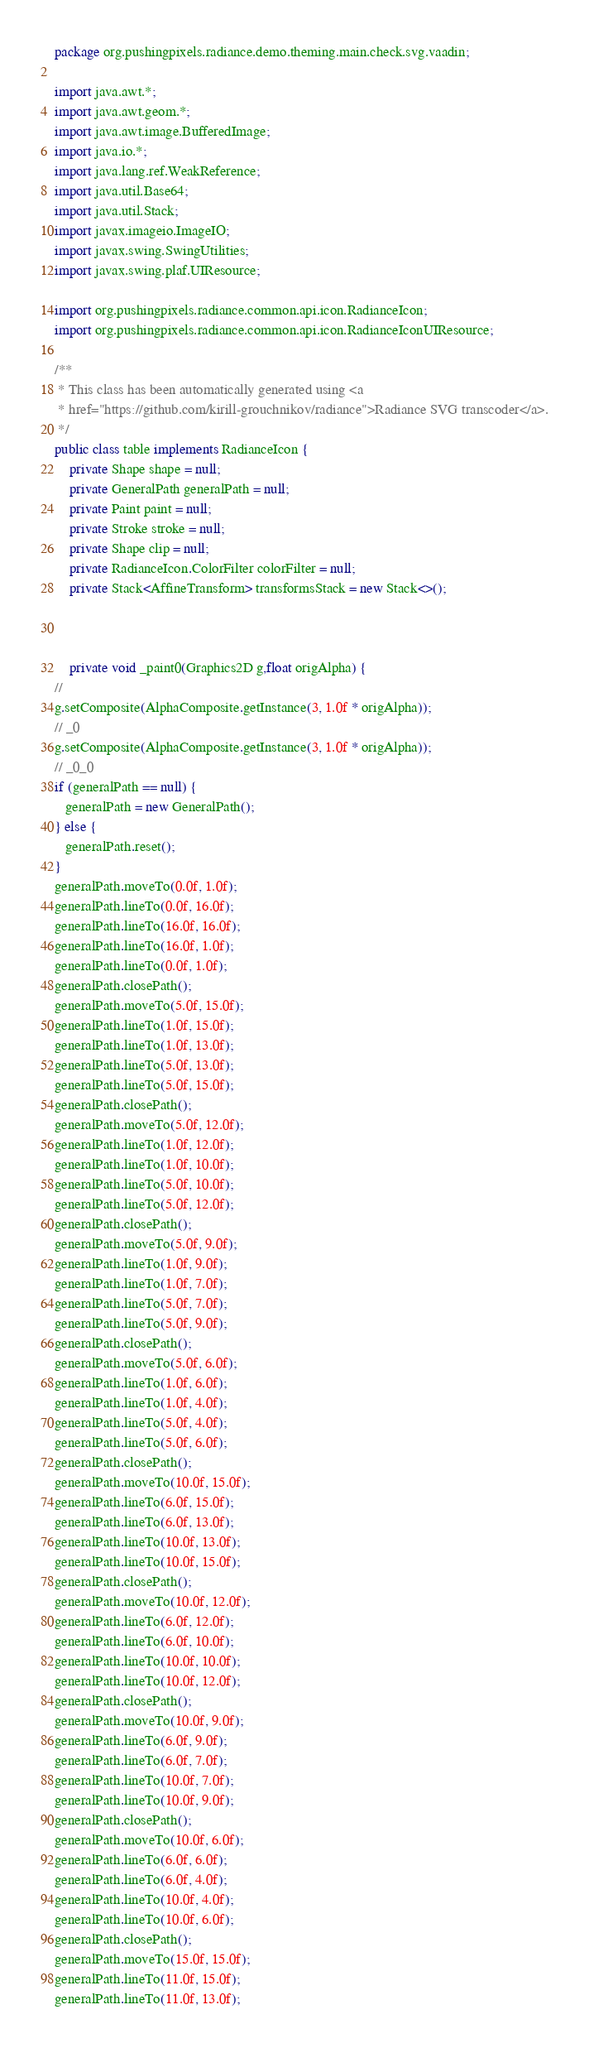<code> <loc_0><loc_0><loc_500><loc_500><_Java_>package org.pushingpixels.radiance.demo.theming.main.check.svg.vaadin;

import java.awt.*;
import java.awt.geom.*;
import java.awt.image.BufferedImage;
import java.io.*;
import java.lang.ref.WeakReference;
import java.util.Base64;
import java.util.Stack;
import javax.imageio.ImageIO;
import javax.swing.SwingUtilities;
import javax.swing.plaf.UIResource;

import org.pushingpixels.radiance.common.api.icon.RadianceIcon;
import org.pushingpixels.radiance.common.api.icon.RadianceIconUIResource;

/**
 * This class has been automatically generated using <a
 * href="https://github.com/kirill-grouchnikov/radiance">Radiance SVG transcoder</a>.
 */
public class table implements RadianceIcon {
    private Shape shape = null;
    private GeneralPath generalPath = null;
    private Paint paint = null;
    private Stroke stroke = null;
    private Shape clip = null;
    private RadianceIcon.ColorFilter colorFilter = null;
    private Stack<AffineTransform> transformsStack = new Stack<>();

    

	private void _paint0(Graphics2D g,float origAlpha) {
// 
g.setComposite(AlphaComposite.getInstance(3, 1.0f * origAlpha));
// _0
g.setComposite(AlphaComposite.getInstance(3, 1.0f * origAlpha));
// _0_0
if (generalPath == null) {
   generalPath = new GeneralPath();
} else {
   generalPath.reset();
}
generalPath.moveTo(0.0f, 1.0f);
generalPath.lineTo(0.0f, 16.0f);
generalPath.lineTo(16.0f, 16.0f);
generalPath.lineTo(16.0f, 1.0f);
generalPath.lineTo(0.0f, 1.0f);
generalPath.closePath();
generalPath.moveTo(5.0f, 15.0f);
generalPath.lineTo(1.0f, 15.0f);
generalPath.lineTo(1.0f, 13.0f);
generalPath.lineTo(5.0f, 13.0f);
generalPath.lineTo(5.0f, 15.0f);
generalPath.closePath();
generalPath.moveTo(5.0f, 12.0f);
generalPath.lineTo(1.0f, 12.0f);
generalPath.lineTo(1.0f, 10.0f);
generalPath.lineTo(5.0f, 10.0f);
generalPath.lineTo(5.0f, 12.0f);
generalPath.closePath();
generalPath.moveTo(5.0f, 9.0f);
generalPath.lineTo(1.0f, 9.0f);
generalPath.lineTo(1.0f, 7.0f);
generalPath.lineTo(5.0f, 7.0f);
generalPath.lineTo(5.0f, 9.0f);
generalPath.closePath();
generalPath.moveTo(5.0f, 6.0f);
generalPath.lineTo(1.0f, 6.0f);
generalPath.lineTo(1.0f, 4.0f);
generalPath.lineTo(5.0f, 4.0f);
generalPath.lineTo(5.0f, 6.0f);
generalPath.closePath();
generalPath.moveTo(10.0f, 15.0f);
generalPath.lineTo(6.0f, 15.0f);
generalPath.lineTo(6.0f, 13.0f);
generalPath.lineTo(10.0f, 13.0f);
generalPath.lineTo(10.0f, 15.0f);
generalPath.closePath();
generalPath.moveTo(10.0f, 12.0f);
generalPath.lineTo(6.0f, 12.0f);
generalPath.lineTo(6.0f, 10.0f);
generalPath.lineTo(10.0f, 10.0f);
generalPath.lineTo(10.0f, 12.0f);
generalPath.closePath();
generalPath.moveTo(10.0f, 9.0f);
generalPath.lineTo(6.0f, 9.0f);
generalPath.lineTo(6.0f, 7.0f);
generalPath.lineTo(10.0f, 7.0f);
generalPath.lineTo(10.0f, 9.0f);
generalPath.closePath();
generalPath.moveTo(10.0f, 6.0f);
generalPath.lineTo(6.0f, 6.0f);
generalPath.lineTo(6.0f, 4.0f);
generalPath.lineTo(10.0f, 4.0f);
generalPath.lineTo(10.0f, 6.0f);
generalPath.closePath();
generalPath.moveTo(15.0f, 15.0f);
generalPath.lineTo(11.0f, 15.0f);
generalPath.lineTo(11.0f, 13.0f);</code> 